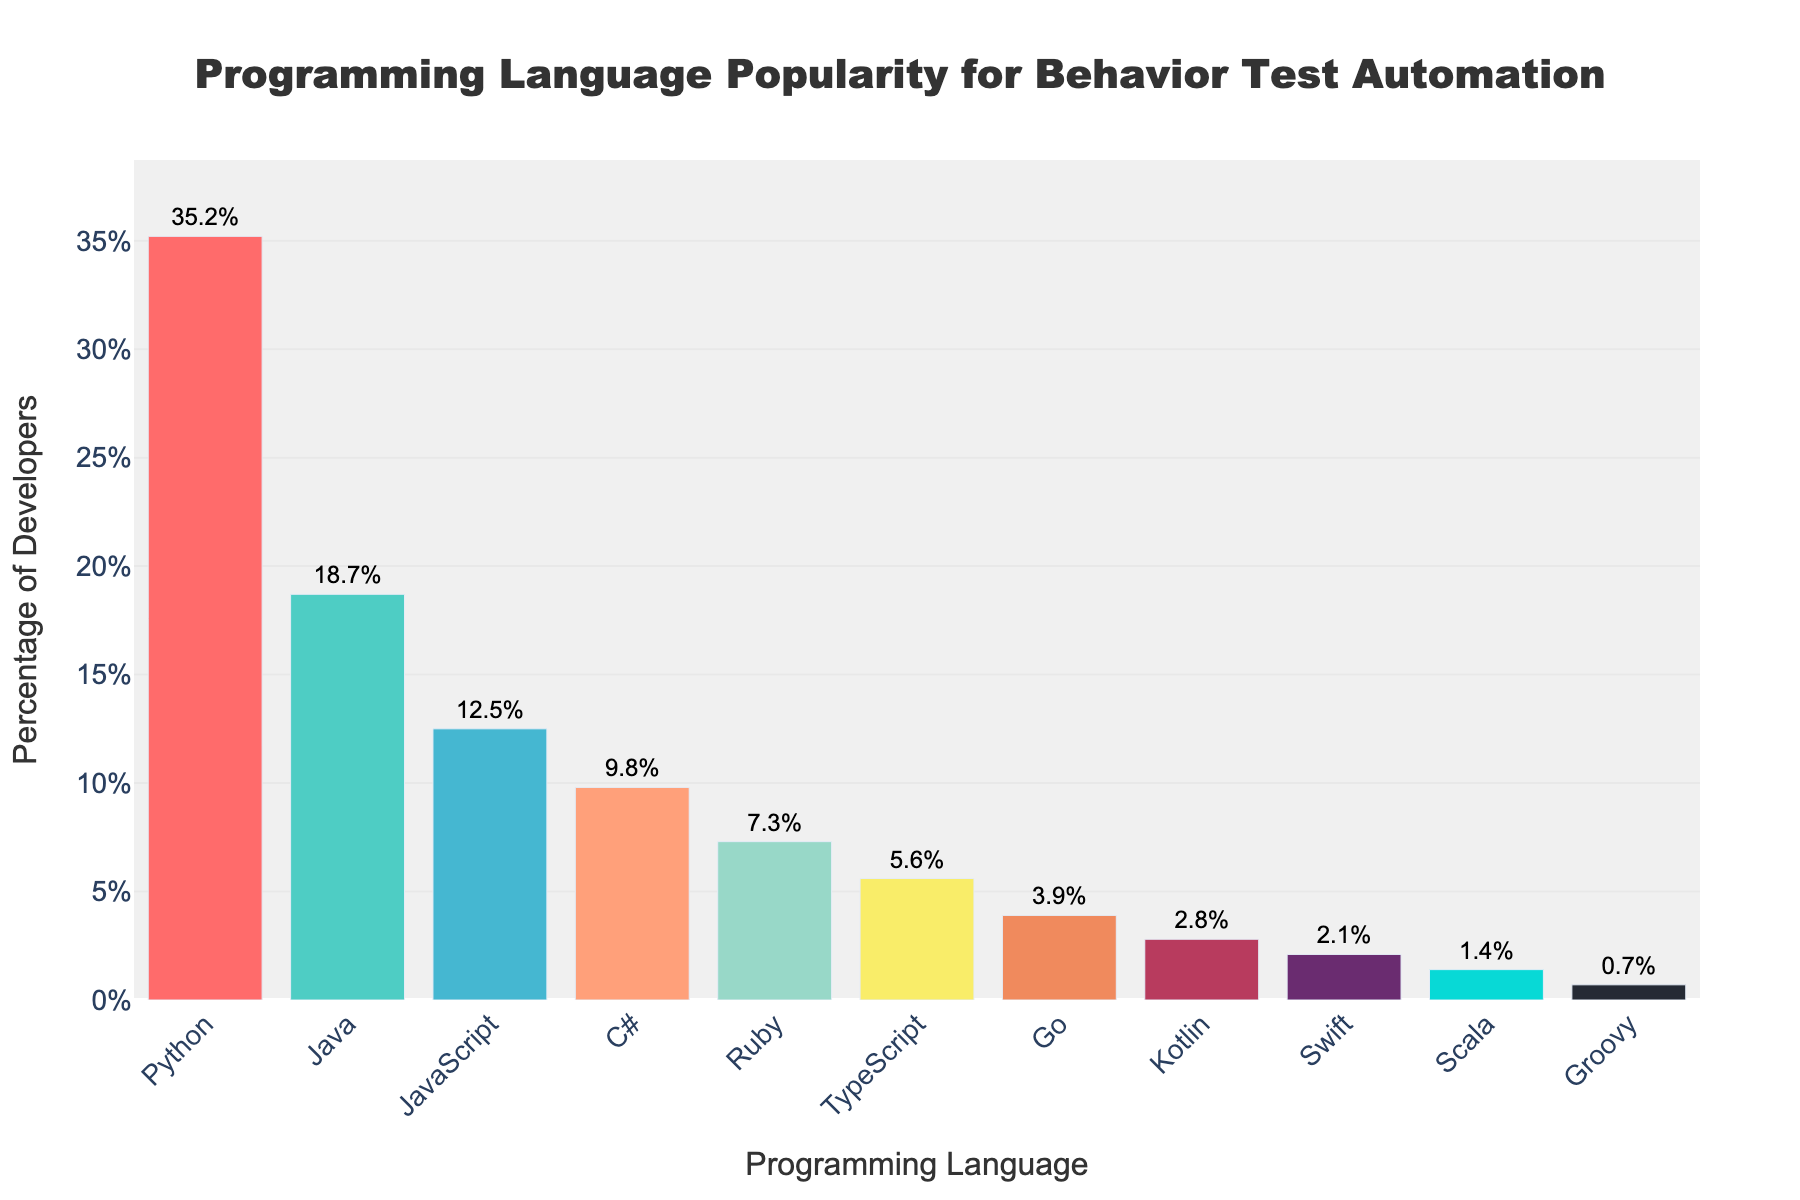Which programming language is the most popular for behavior test automation? By observing the bar chart, the bar representing Python is the tallest, indicating it has the highest percentage.
Answer: Python What is the difference in popularity between Python and Java? To find the difference, subtract the percentage of Java (18.7%) from Python (35.2%). This gives 35.2% - 18.7% = 16.5%.
Answer: 16.5% How many languages have a popularity percentage above 10%? Looking at the bars, Python, Java, and JavaScript each have heights above 10%. Thus, there are three languages with percentages above 10%.
Answer: 3 Which language has just slightly higher popularity than TypeScript? TypeScript is at 5.6%, and the next highest bar corresponds to Ruby, which stands at 7.3%. Hence, Ruby is slightly higher than TypeScript.
Answer: Ruby What is the combined popularity percentage of Go, Kotlin, and Swift? Adding the percentages for Go (3.9%), Kotlin (2.8%), and Swift (2.1%) gives 3.9% + 2.8% + 2.1% = 8.8%.
Answer: 8.8% Are there more languages with popularity above or below 5%? Counting languages above 5%: Python, Java, JavaScript, C#, Ruby, TypeScript (6 languages). Counting languages below 5%: Go, Kotlin, Swift, Scala, Groovy (5 languages). Hence, there are more languages above 5%.
Answer: More above 5% How much more popular is C# compared to Ruby? To find the difference in popularity, subtract Ruby's percentage (7.3%) from C#'s percentage (9.8%). This gives 9.8% - 7.3% = 2.5%.
Answer: 2.5% What color represents the bar for Swift? By observing the figure's color scheme, the color corresponding to Swift is the ninth bar, which is blue.
Answer: Blue What is the median popularity percentage of the programming languages? Arrange percentages in ascending order: 0.7, 1.4, 2.1, 2.8, 3.9, 5.6, 7.3, 9.8, 12.5, 18.7, 35.2. The middle value (6th position) is 5.6%, which represents TypeScript.
Answer: 5.6% Which programming language is least popular and what percentage does it hold? The shortest bar represents Groovy, which holds the least popularity at 0.7%.
Answer: Groovy, 0.7% 